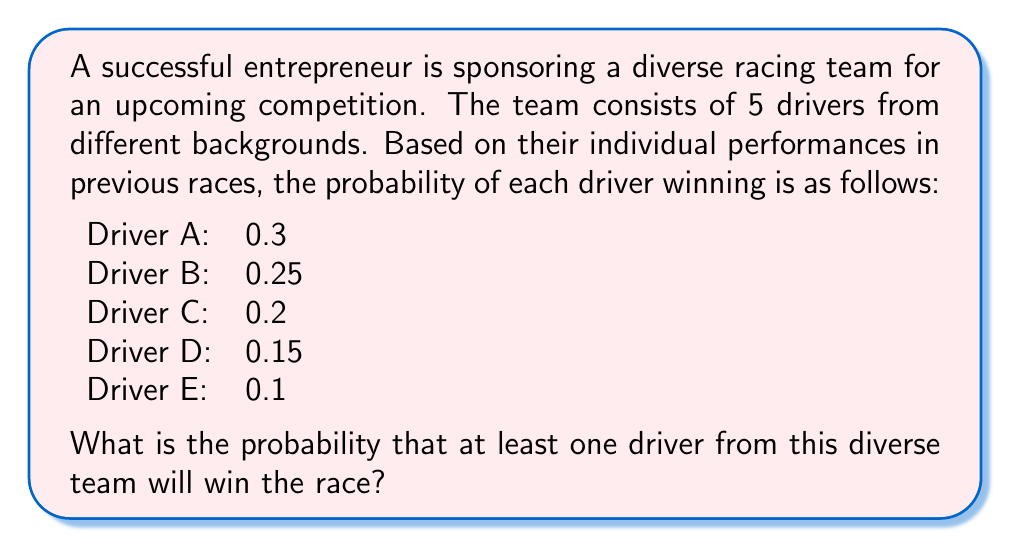Give your solution to this math problem. To solve this problem, we'll use the concept of probability of complementary events.

Step 1: Calculate the probability that none of the drivers win.
The probability of a driver not winning is 1 minus their probability of winning.

$P(\text{A not winning}) = 1 - 0.3 = 0.7$
$P(\text{B not winning}) = 1 - 0.25 = 0.75$
$P(\text{C not winning}) = 1 - 0.2 = 0.8$
$P(\text{D not winning}) = 1 - 0.15 = 0.85$
$P(\text{E not winning}) = 1 - 0.1 = 0.9$

Step 2: Calculate the probability that all drivers lose.
Assuming the events are independent, we multiply these probabilities:

$$P(\text{all lose}) = 0.7 \times 0.75 \times 0.8 \times 0.85 \times 0.9 = 0.32130$$

Step 3: Calculate the probability that at least one driver wins.
This is the complement of the probability that all drivers lose:

$$P(\text{at least one wins}) = 1 - P(\text{all lose}) = 1 - 0.32130 = 0.67870$$

Therefore, the probability that at least one driver from the diverse team will win the race is approximately 0.67870 or 67.87%.
Answer: $0.67870$ or $67.87\%$ 